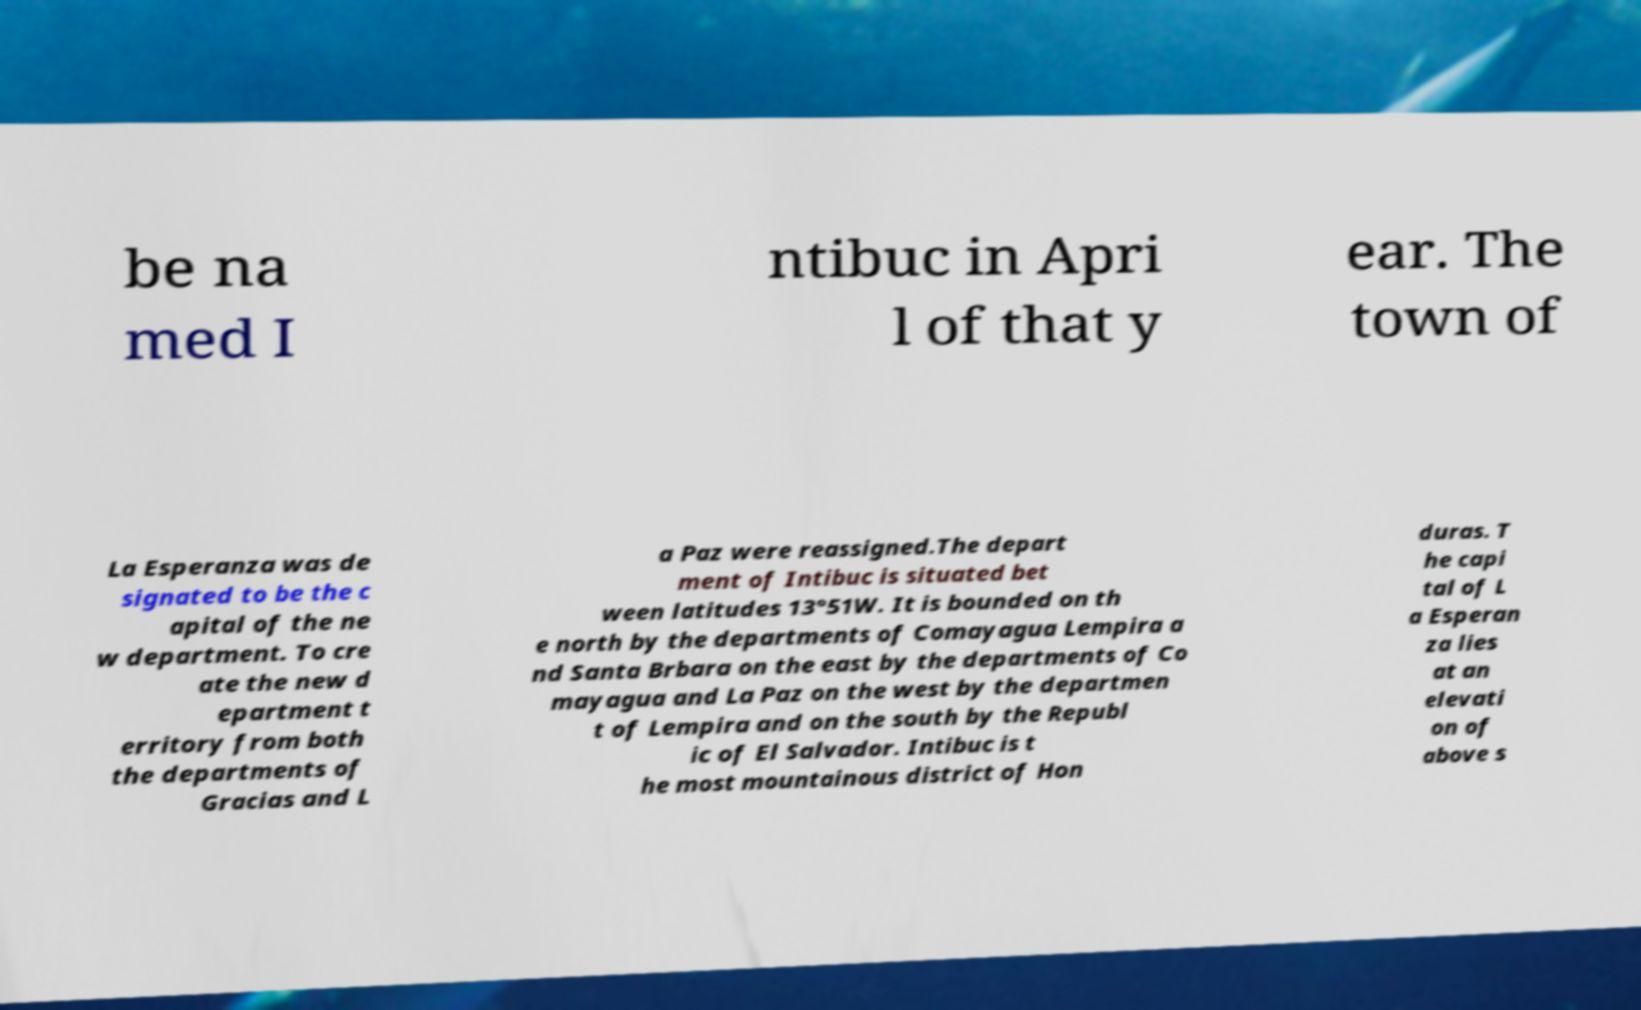Please identify and transcribe the text found in this image. be na med I ntibuc in Apri l of that y ear. The town of La Esperanza was de signated to be the c apital of the ne w department. To cre ate the new d epartment t erritory from both the departments of Gracias and L a Paz were reassigned.The depart ment of Intibuc is situated bet ween latitudes 13°51W. It is bounded on th e north by the departments of Comayagua Lempira a nd Santa Brbara on the east by the departments of Co mayagua and La Paz on the west by the departmen t of Lempira and on the south by the Republ ic of El Salvador. Intibuc is t he most mountainous district of Hon duras. T he capi tal of L a Esperan za lies at an elevati on of above s 